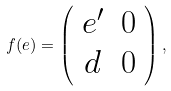Convert formula to latex. <formula><loc_0><loc_0><loc_500><loc_500>f ( e ) = \left ( \begin{array} { c c } e ^ { \prime } & 0 \\ d & 0 \end{array} \right ) ,</formula> 